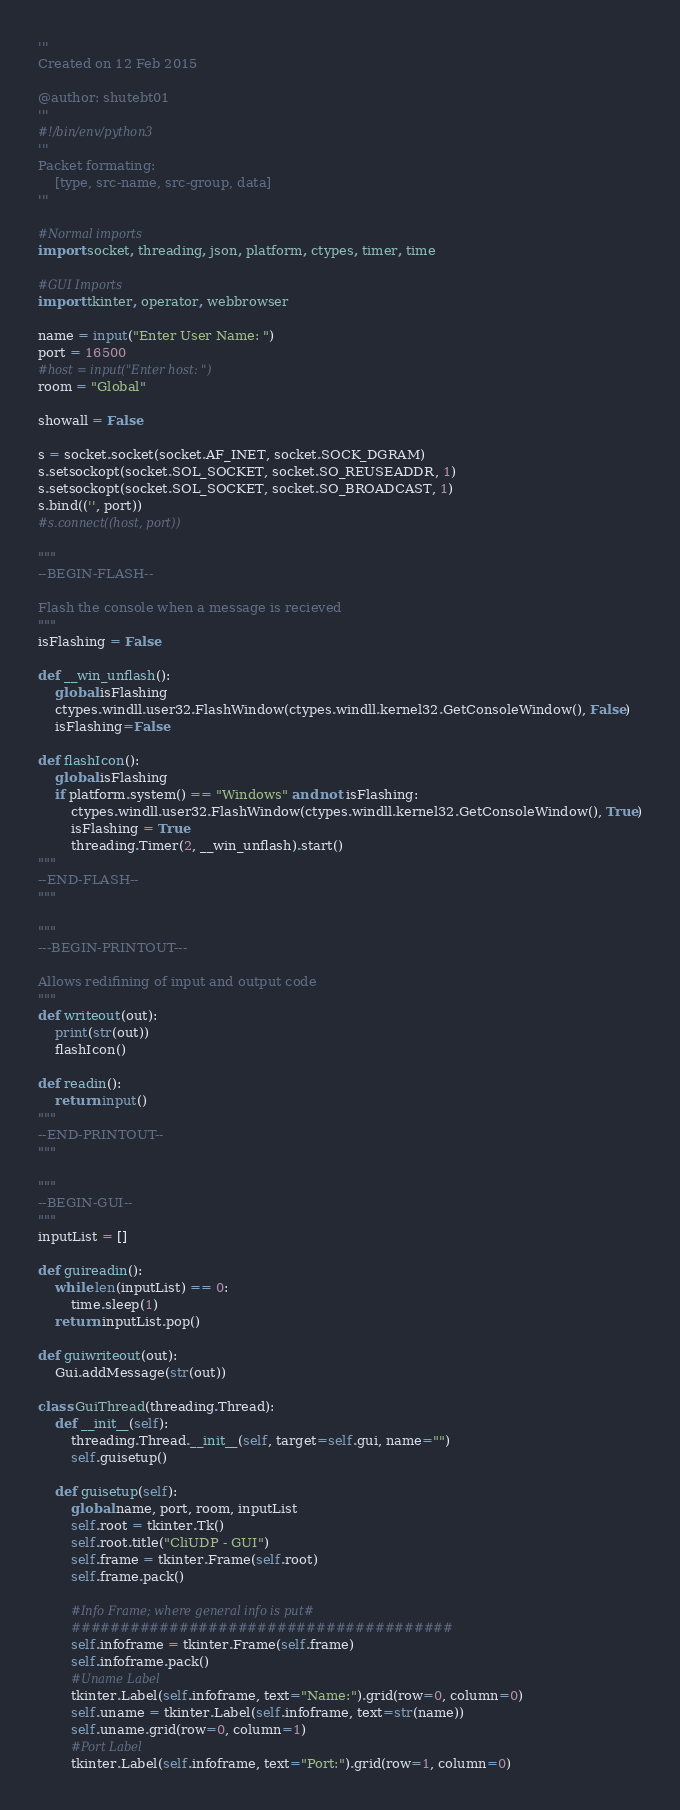Convert code to text. <code><loc_0><loc_0><loc_500><loc_500><_Python_>'''
Created on 12 Feb 2015

@author: shutebt01
'''
#!/bin/env/python3
'''
Packet formating:
    [type, src-name, src-group, data]
'''

#Normal imports
import socket, threading, json, platform, ctypes, timer, time

#GUI Imports
import tkinter, operator, webbrowser

name = input("Enter User Name: ")
port = 16500
#host = input("Enter host: ")
room = "Global"

showall = False

s = socket.socket(socket.AF_INET, socket.SOCK_DGRAM)
s.setsockopt(socket.SOL_SOCKET, socket.SO_REUSEADDR, 1)
s.setsockopt(socket.SOL_SOCKET, socket.SO_BROADCAST, 1)
s.bind(('', port))
#s.connect((host, port))

"""
--BEGIN-FLASH--

Flash the console when a message is recieved
"""
isFlashing = False

def __win_unflash():
    global isFlashing
    ctypes.windll.user32.FlashWindow(ctypes.windll.kernel32.GetConsoleWindow(), False)
    isFlashing=False

def flashIcon():
    global isFlashing
    if platform.system() == "Windows" and not isFlashing:
        ctypes.windll.user32.FlashWindow(ctypes.windll.kernel32.GetConsoleWindow(), True)
        isFlashing = True
        threading.Timer(2, __win_unflash).start()
"""
--END-FLASH--
"""

"""
---BEGIN-PRINTOUT---

Allows redifining of input and output code
"""
def writeout(out):
    print(str(out))
    flashIcon()

def readin():
    return input()
"""
--END-PRINTOUT--
"""

"""
--BEGIN-GUI--
"""
inputList = []

def guireadin():
    while len(inputList) == 0:
        time.sleep(1)
    return inputList.pop()

def guiwriteout(out):
    Gui.addMessage(str(out))

class GuiThread(threading.Thread):
    def __init__(self):
        threading.Thread.__init__(self, target=self.gui, name="")
        self.guisetup()
    
    def guisetup(self):
        global name, port, room, inputList
        self.root = tkinter.Tk()
        self.root.title("CliUDP - GUI")
        self.frame = tkinter.Frame(self.root)
        self.frame.pack()

        #Info Frame; where general info is put#
        #######################################
        self.infoframe = tkinter.Frame(self.frame)
        self.infoframe.pack()
        #Uname Label
        tkinter.Label(self.infoframe, text="Name:").grid(row=0, column=0)
        self.uname = tkinter.Label(self.infoframe, text=str(name))
        self.uname.grid(row=0, column=1)
        #Port Label
        tkinter.Label(self.infoframe, text="Port:").grid(row=1, column=0)</code> 